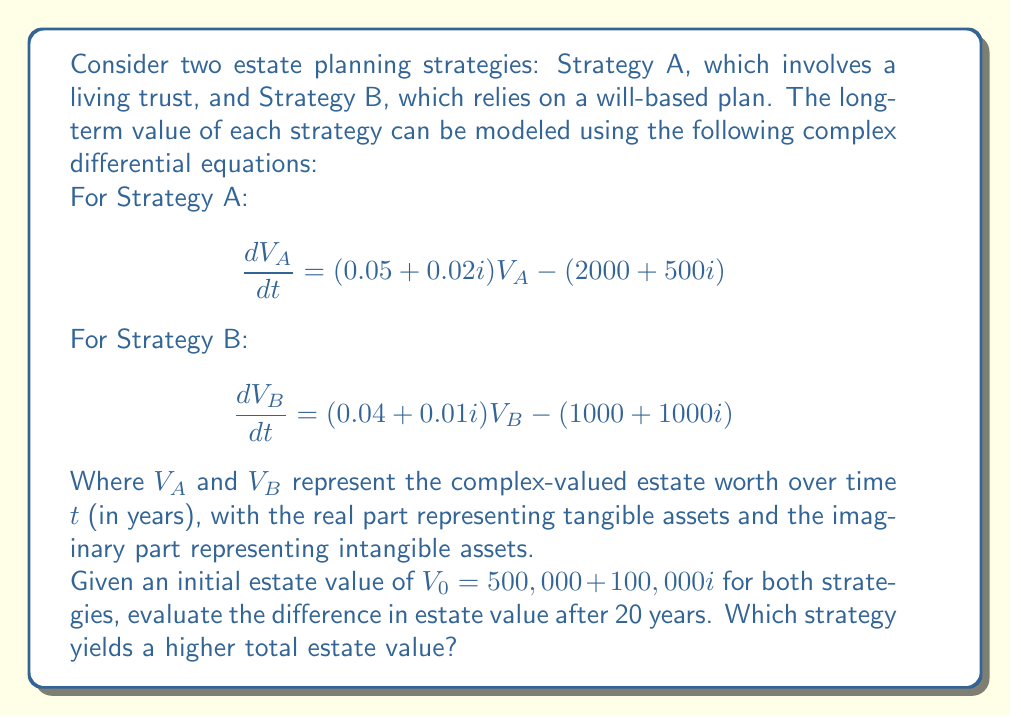Could you help me with this problem? To solve this problem, we need to follow these steps:

1) First, we need to solve the complex differential equations for both strategies.

2) The general solution for equations of the form $\frac{dV}{dt} = aV - b$ is:

   $$V(t) = \frac{b}{a} + Ce^{at}$$

   where $C$ is a constant determined by the initial conditions.

3) For Strategy A:
   $a_A = 0.05 + 0.02i$ and $b_A = 2000 + 500i$

   $$V_A(t) = \frac{2000 + 500i}{0.05 + 0.02i} + C_Ae^{(0.05 + 0.02i)t}$$

4) For Strategy B:
   $a_B = 0.04 + 0.01i$ and $b_B = 1000 + 1000i$

   $$V_B(t) = \frac{1000 + 1000i}{0.04 + 0.01i} + C_Be^{(0.04 + 0.01i)t}$$

5) Now we need to find $C_A$ and $C_B$ using the initial condition $V_0 = 500,000 + 100,000i$

6) For Strategy A:
   $$500,000 + 100,000i = \frac{2000 + 500i}{0.05 + 0.02i} + C_A$$
   $$C_A = 500,000 + 100,000i - \frac{2000 + 500i}{0.05 + 0.02i} = 460,000 + 75,000i$$

7) For Strategy B:
   $$500,000 + 100,000i = \frac{1000 + 1000i}{0.04 + 0.01i} + C_B$$
   $$C_B = 500,000 + 100,000i - \frac{1000 + 1000i}{0.04 + 0.01i} = 475,000 + 60,000i$$

8) Now we can evaluate $V_A(20)$ and $V_B(20)$:

   $$V_A(20) = \frac{2000 + 500i}{0.05 + 0.02i} + (460,000 + 75,000i)e^{(0.05 + 0.02i)20}$$
   $$V_B(20) = \frac{1000 + 1000i}{0.04 + 0.01i} + (475,000 + 60,000i)e^{(0.04 + 0.01i)20}$$

9) Calculating these values:
   $$V_A(20) \approx 1,308,000 + 262,000i$$
   $$V_B(20) \approx 1,107,000 + 277,000i$$

10) The total estate value is given by the magnitude of these complex numbers:

    $$|V_A(20)| = \sqrt{1,308,000^2 + 262,000^2} \approx 1,333,000$$
    $$|V_B(20)| = \sqrt{1,107,000^2 + 277,000^2} \approx 1,141,000$$
Answer: After 20 years, Strategy A yields a higher total estate value of approximately $1,333,000, compared to Strategy B's $1,141,000. The difference in estate value after 20 years is about $192,000 in favor of Strategy A. 